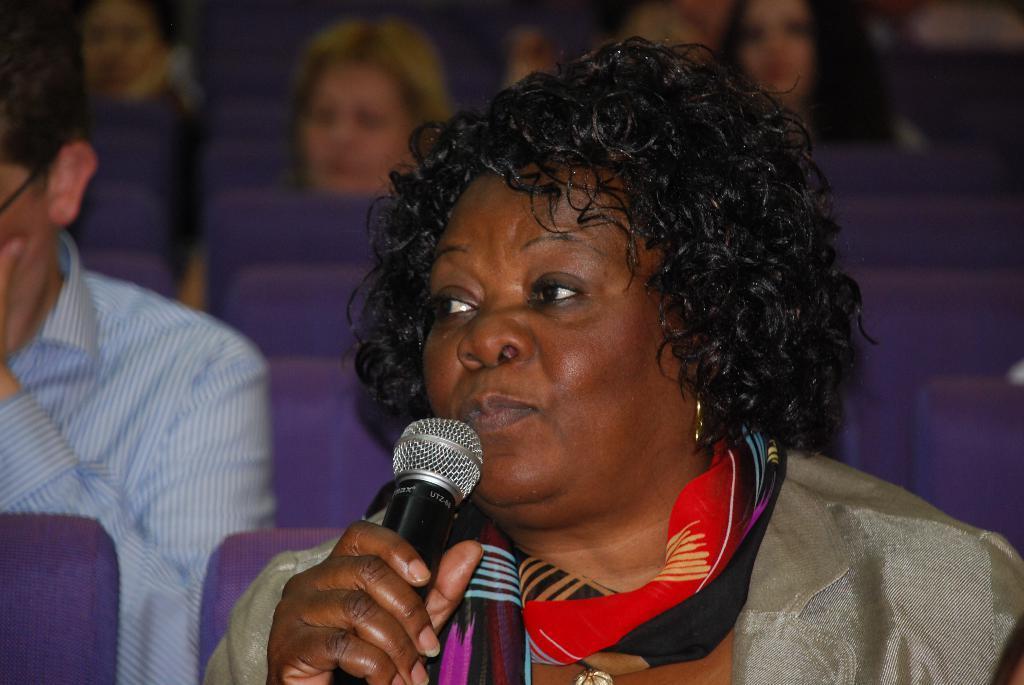How would you summarize this image in a sentence or two? In this image, we can see a woman is holding a microphone. She wear a cream color dress and colorful scarf on her neck. And the left side of the image, we can see human is wearing a shirt. They all are sat on the chair. Chairs are in blue color. The background, we can see few peoples are sat on the chair. 